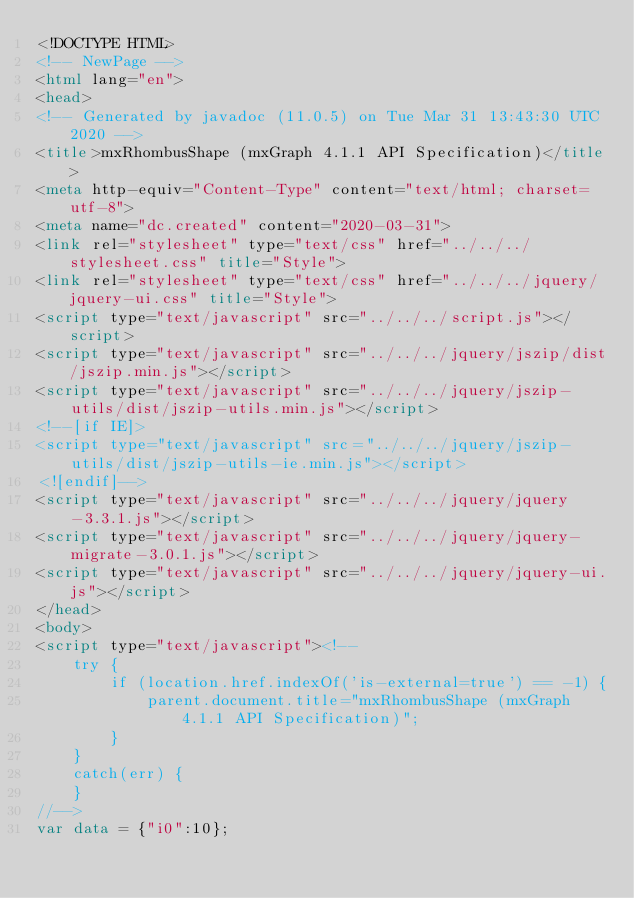Convert code to text. <code><loc_0><loc_0><loc_500><loc_500><_HTML_><!DOCTYPE HTML>
<!-- NewPage -->
<html lang="en">
<head>
<!-- Generated by javadoc (11.0.5) on Tue Mar 31 13:43:30 UTC 2020 -->
<title>mxRhombusShape (mxGraph 4.1.1 API Specification)</title>
<meta http-equiv="Content-Type" content="text/html; charset=utf-8">
<meta name="dc.created" content="2020-03-31">
<link rel="stylesheet" type="text/css" href="../../../stylesheet.css" title="Style">
<link rel="stylesheet" type="text/css" href="../../../jquery/jquery-ui.css" title="Style">
<script type="text/javascript" src="../../../script.js"></script>
<script type="text/javascript" src="../../../jquery/jszip/dist/jszip.min.js"></script>
<script type="text/javascript" src="../../../jquery/jszip-utils/dist/jszip-utils.min.js"></script>
<!--[if IE]>
<script type="text/javascript" src="../../../jquery/jszip-utils/dist/jszip-utils-ie.min.js"></script>
<![endif]-->
<script type="text/javascript" src="../../../jquery/jquery-3.3.1.js"></script>
<script type="text/javascript" src="../../../jquery/jquery-migrate-3.0.1.js"></script>
<script type="text/javascript" src="../../../jquery/jquery-ui.js"></script>
</head>
<body>
<script type="text/javascript"><!--
    try {
        if (location.href.indexOf('is-external=true') == -1) {
            parent.document.title="mxRhombusShape (mxGraph 4.1.1 API Specification)";
        }
    }
    catch(err) {
    }
//-->
var data = {"i0":10};</code> 